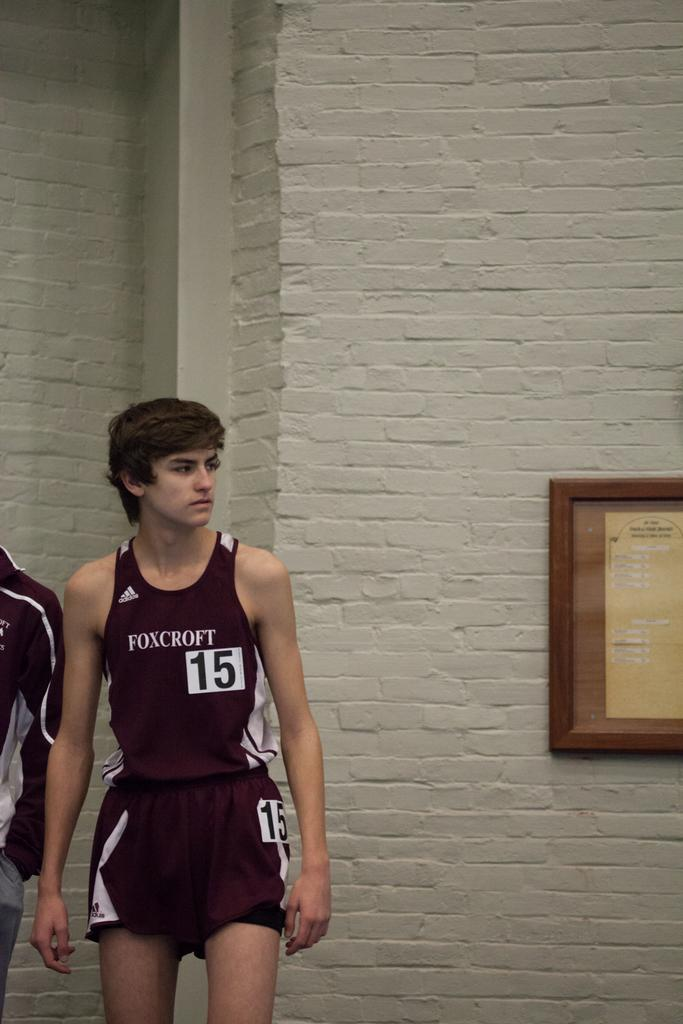<image>
Write a terse but informative summary of the picture. A boy is wearing a gym outfit that says Foxcroft 15. 